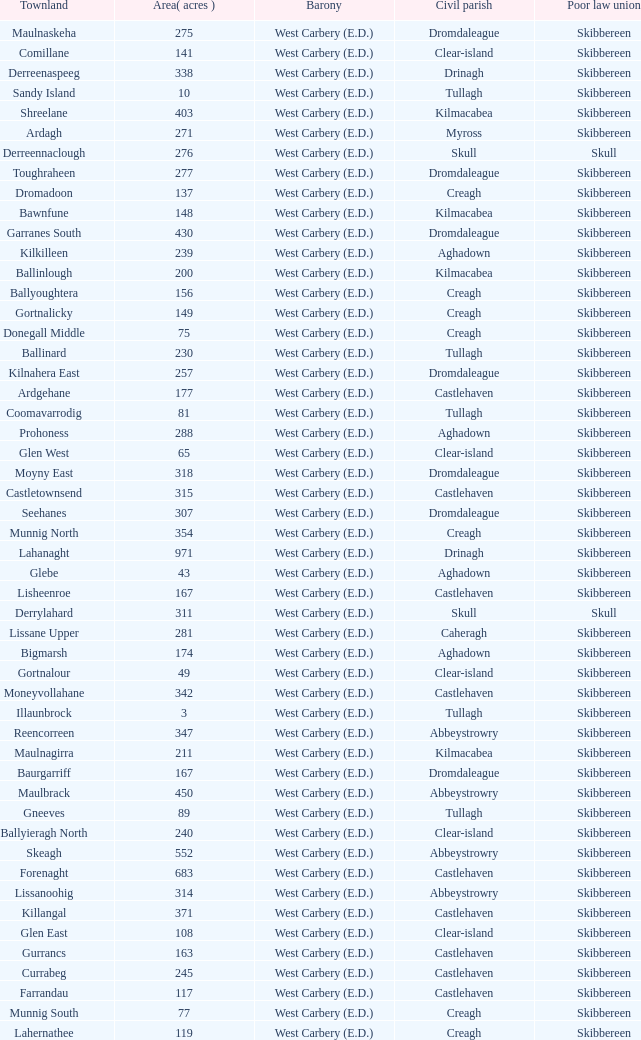What are the areas (in acres) of the Kilnahera East townland? 257.0. 